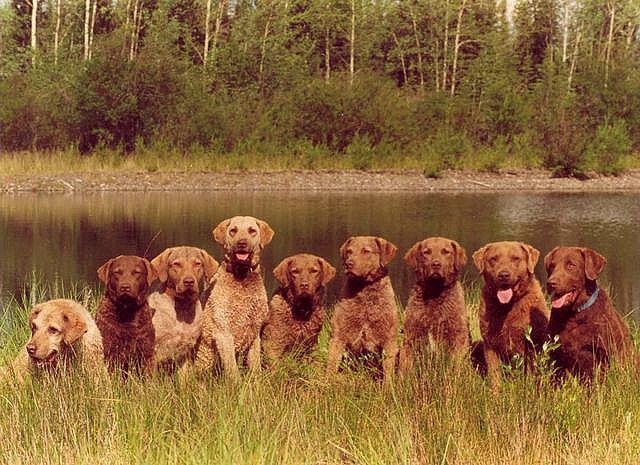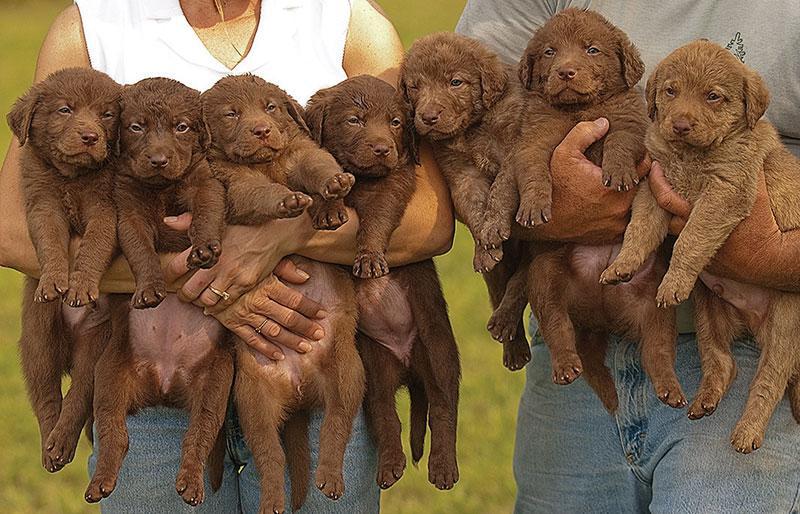The first image is the image on the left, the second image is the image on the right. Examine the images to the left and right. Is the description "More than half a dozen dogs are lined up in each image." accurate? Answer yes or no. Yes. The first image is the image on the left, the second image is the image on the right. Given the left and right images, does the statement "An image includes a hunting dog and a captured prey bird." hold true? Answer yes or no. No. 